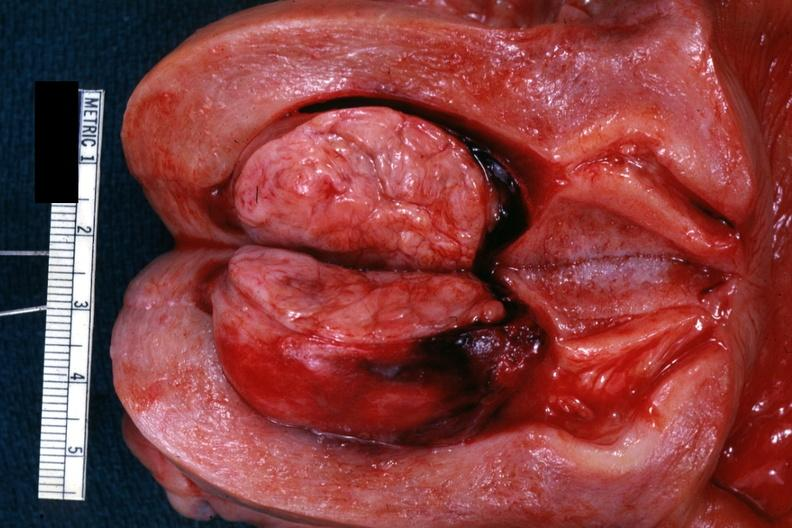what is present?
Answer the question using a single word or phrase. Female reproductive 